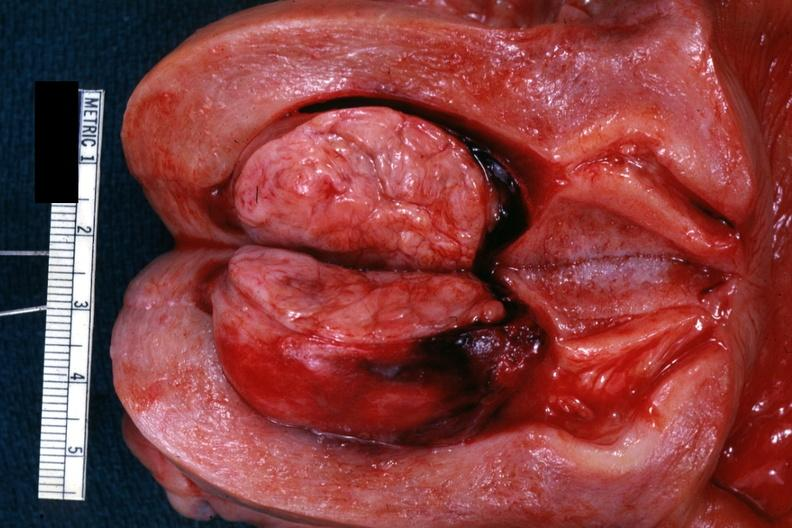what is present?
Answer the question using a single word or phrase. Female reproductive 